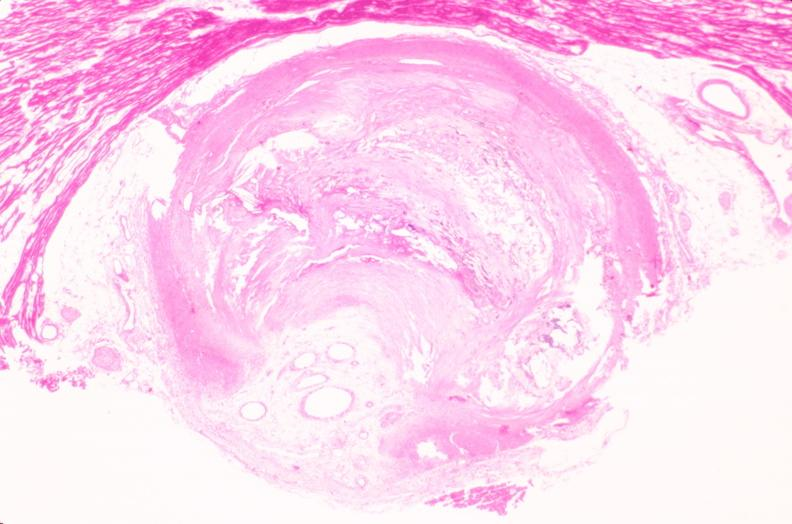what is present?
Answer the question using a single word or phrase. Cardiovascular 